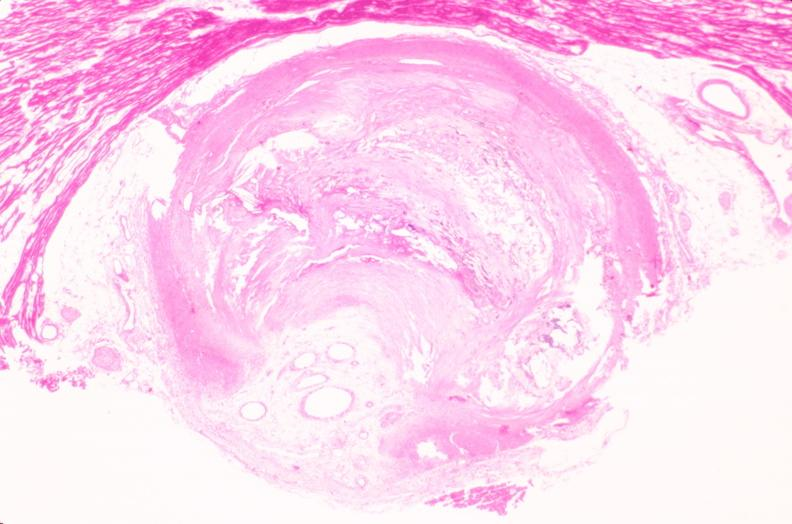what is present?
Answer the question using a single word or phrase. Cardiovascular 